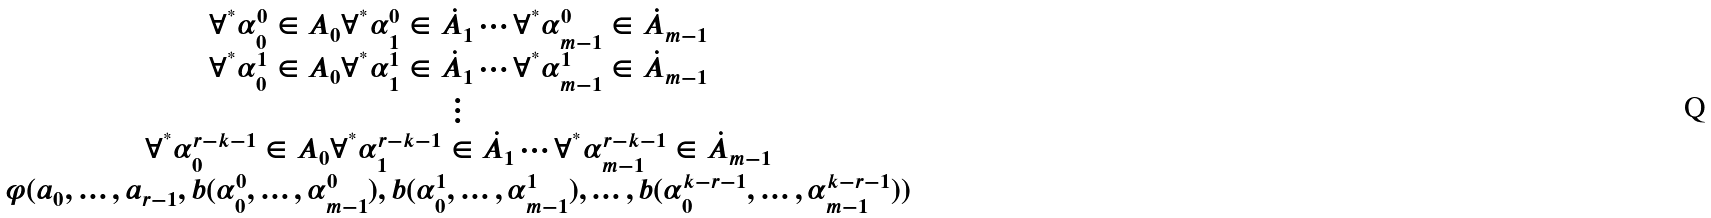Convert formula to latex. <formula><loc_0><loc_0><loc_500><loc_500>\begin{matrix} \forall ^ { ^ { * } } \alpha ^ { 0 } _ { 0 } \in A _ { 0 } \forall ^ { ^ { * } } \alpha ^ { 0 } _ { 1 } \in \dot { A } _ { 1 } \cdots \forall ^ { ^ { * } } \alpha ^ { 0 } _ { m - 1 } \in \dot { A } _ { m - 1 } \\ \forall ^ { ^ { * } } \alpha ^ { 1 } _ { 0 } \in A _ { 0 } \forall ^ { ^ { * } } \alpha ^ { 1 } _ { 1 } \in \dot { A } _ { 1 } \cdots \forall ^ { ^ { * } } \alpha ^ { 1 } _ { m - 1 } \in \dot { A } _ { m - 1 } \\ \vdots \\ \forall ^ { ^ { * } } \alpha ^ { r - k - 1 } _ { 0 } \in A _ { 0 } \forall ^ { ^ { * } } \alpha ^ { r - k - 1 } _ { 1 } \in \dot { A } _ { 1 } \cdots \forall ^ { ^ { * } } \alpha ^ { r - k - 1 } _ { m - 1 } \in \dot { A } _ { m - 1 } \\ \varphi ( a _ { 0 } , \dots , a _ { r - 1 } , b ( \alpha ^ { 0 } _ { 0 } , \dots , \alpha ^ { 0 } _ { m - 1 } ) , b ( \alpha ^ { 1 } _ { 0 } , \dots , \alpha ^ { 1 } _ { m - 1 } ) , \dots , b ( \alpha ^ { k - r - 1 } _ { 0 } , \dots , \alpha ^ { k - r - 1 } _ { m - 1 } ) ) \end{matrix}</formula> 